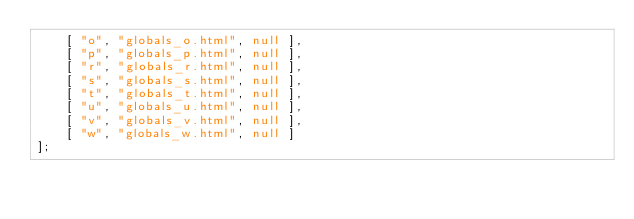Convert code to text. <code><loc_0><loc_0><loc_500><loc_500><_JavaScript_>    [ "o", "globals_o.html", null ],
    [ "p", "globals_p.html", null ],
    [ "r", "globals_r.html", null ],
    [ "s", "globals_s.html", null ],
    [ "t", "globals_t.html", null ],
    [ "u", "globals_u.html", null ],
    [ "v", "globals_v.html", null ],
    [ "w", "globals_w.html", null ]
];</code> 